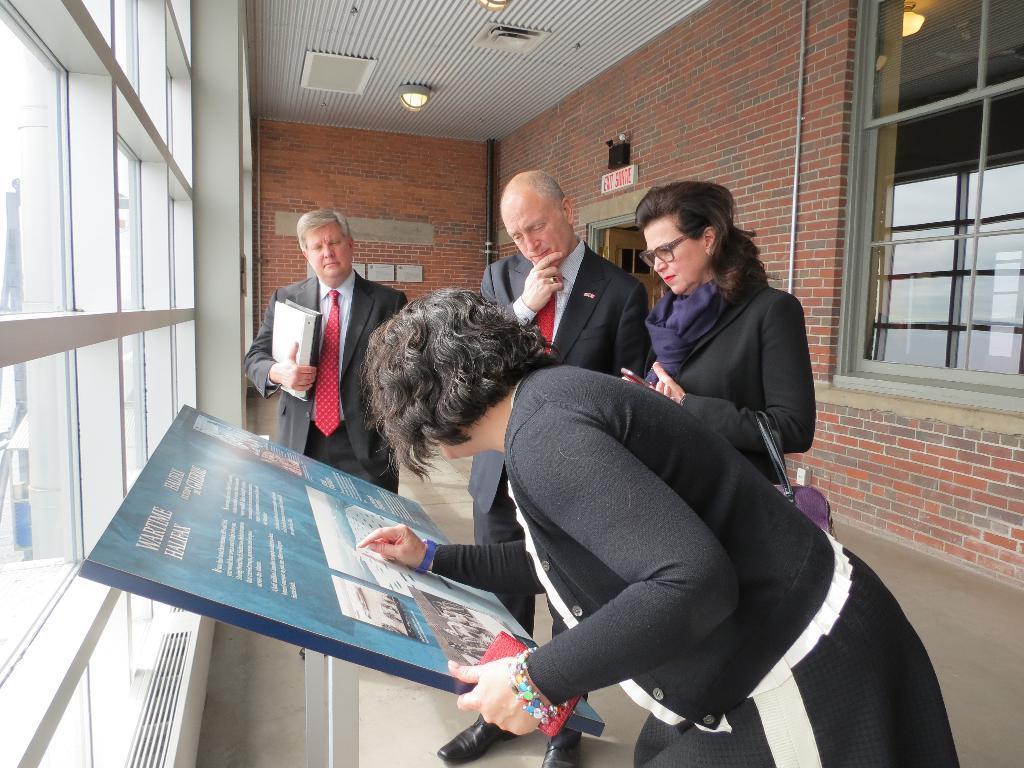Could you give a brief overview of what you see in this image? This image consists of 4 persons. Two are women, two are men. All are wearing coats. There is a board in the middle. There are windows on the right side and left side. There are lights at the top. 